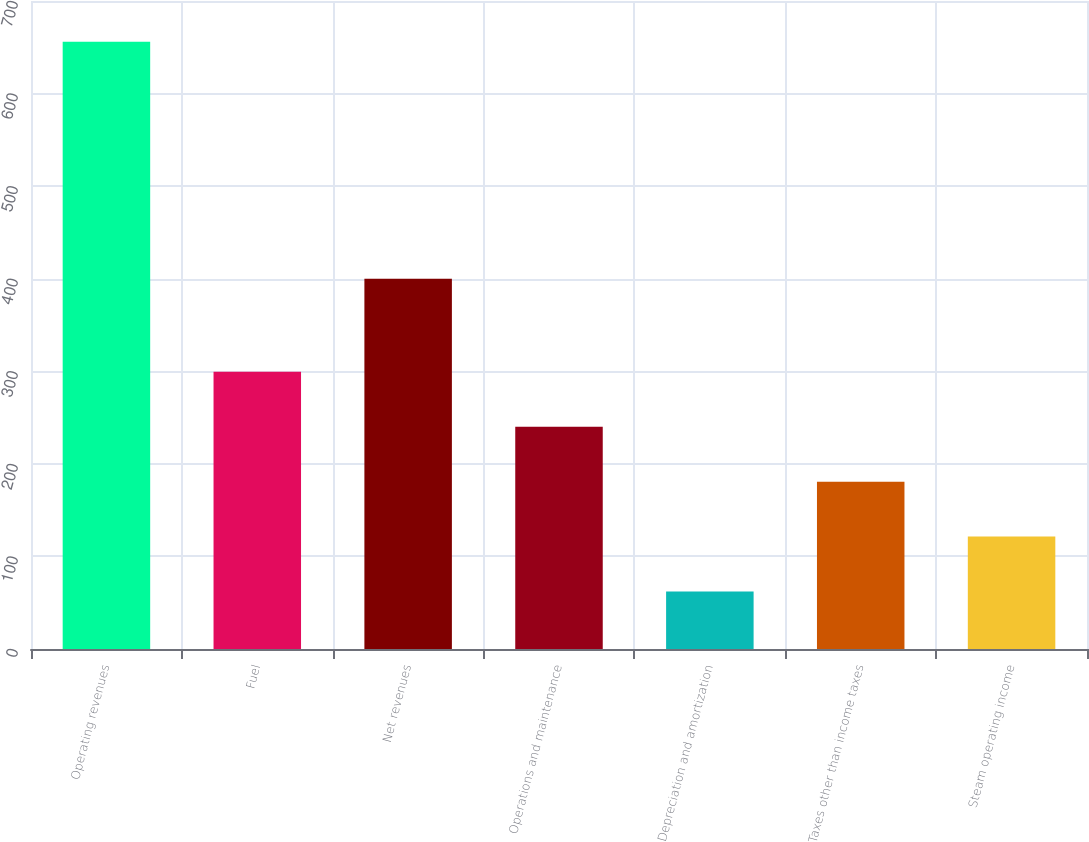Convert chart. <chart><loc_0><loc_0><loc_500><loc_500><bar_chart><fcel>Operating revenues<fcel>Fuel<fcel>Net revenues<fcel>Operations and maintenance<fcel>Depreciation and amortization<fcel>Taxes other than income taxes<fcel>Steam operating income<nl><fcel>656<fcel>299.6<fcel>400<fcel>240.2<fcel>62<fcel>180.8<fcel>121.4<nl></chart> 